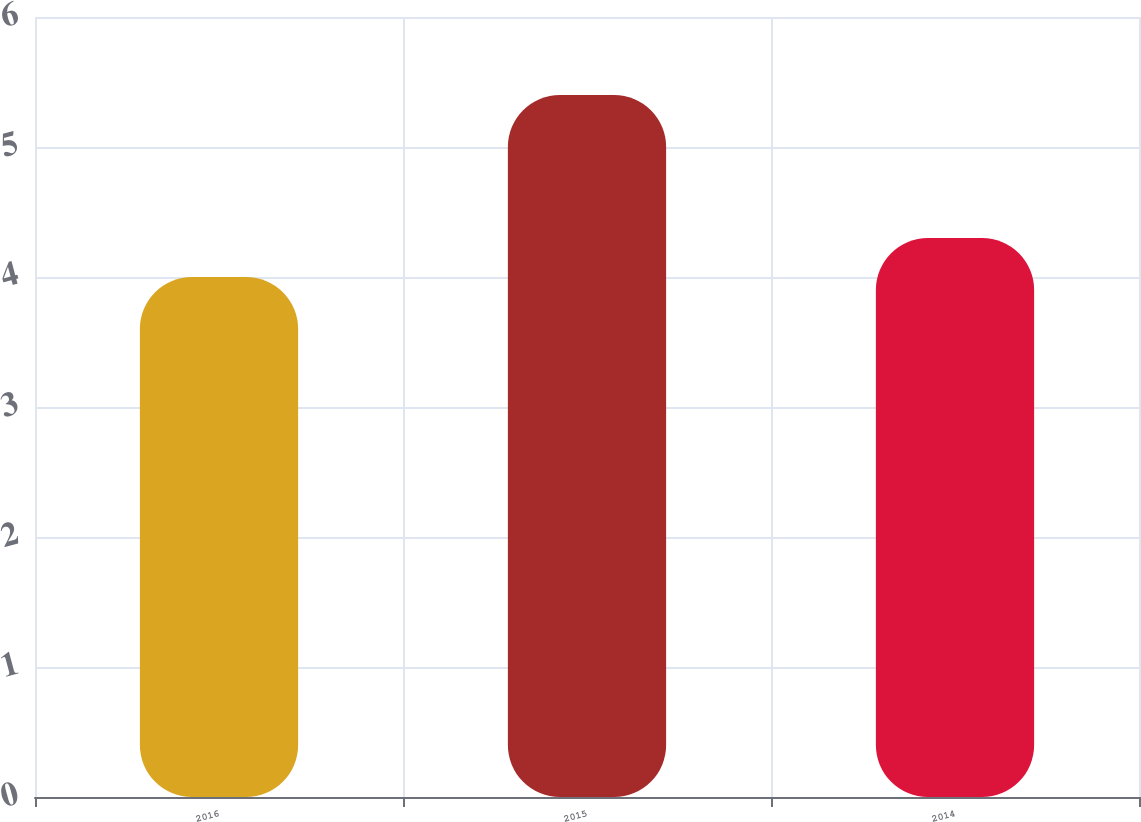Convert chart to OTSL. <chart><loc_0><loc_0><loc_500><loc_500><bar_chart><fcel>2016<fcel>2015<fcel>2014<nl><fcel>4<fcel>5.4<fcel>4.3<nl></chart> 